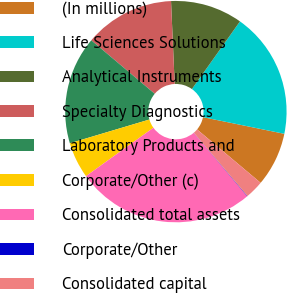Convert chart. <chart><loc_0><loc_0><loc_500><loc_500><pie_chart><fcel>(In millions)<fcel>Life Sciences Solutions<fcel>Analytical Instruments<fcel>Specialty Diagnostics<fcel>Laboratory Products and<fcel>Corporate/Other (c)<fcel>Consolidated total assets<fcel>Corporate/Other<fcel>Consolidated capital<nl><fcel>7.91%<fcel>18.38%<fcel>10.53%<fcel>13.15%<fcel>15.76%<fcel>5.29%<fcel>26.23%<fcel>0.06%<fcel>2.68%<nl></chart> 